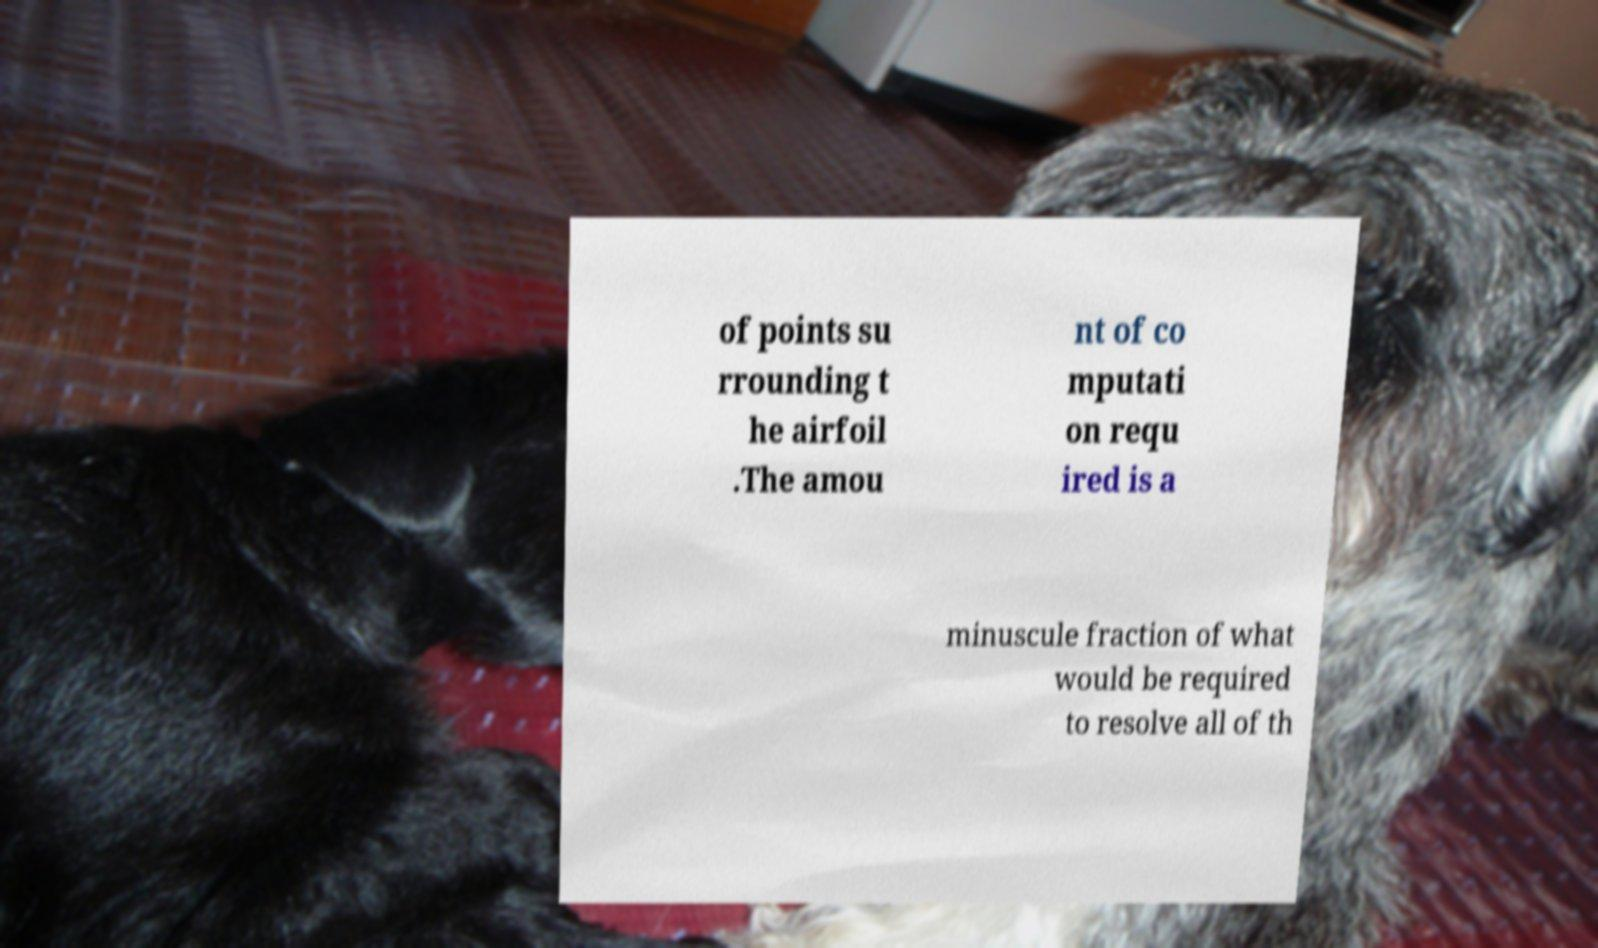There's text embedded in this image that I need extracted. Can you transcribe it verbatim? of points su rrounding t he airfoil .The amou nt of co mputati on requ ired is a minuscule fraction of what would be required to resolve all of th 